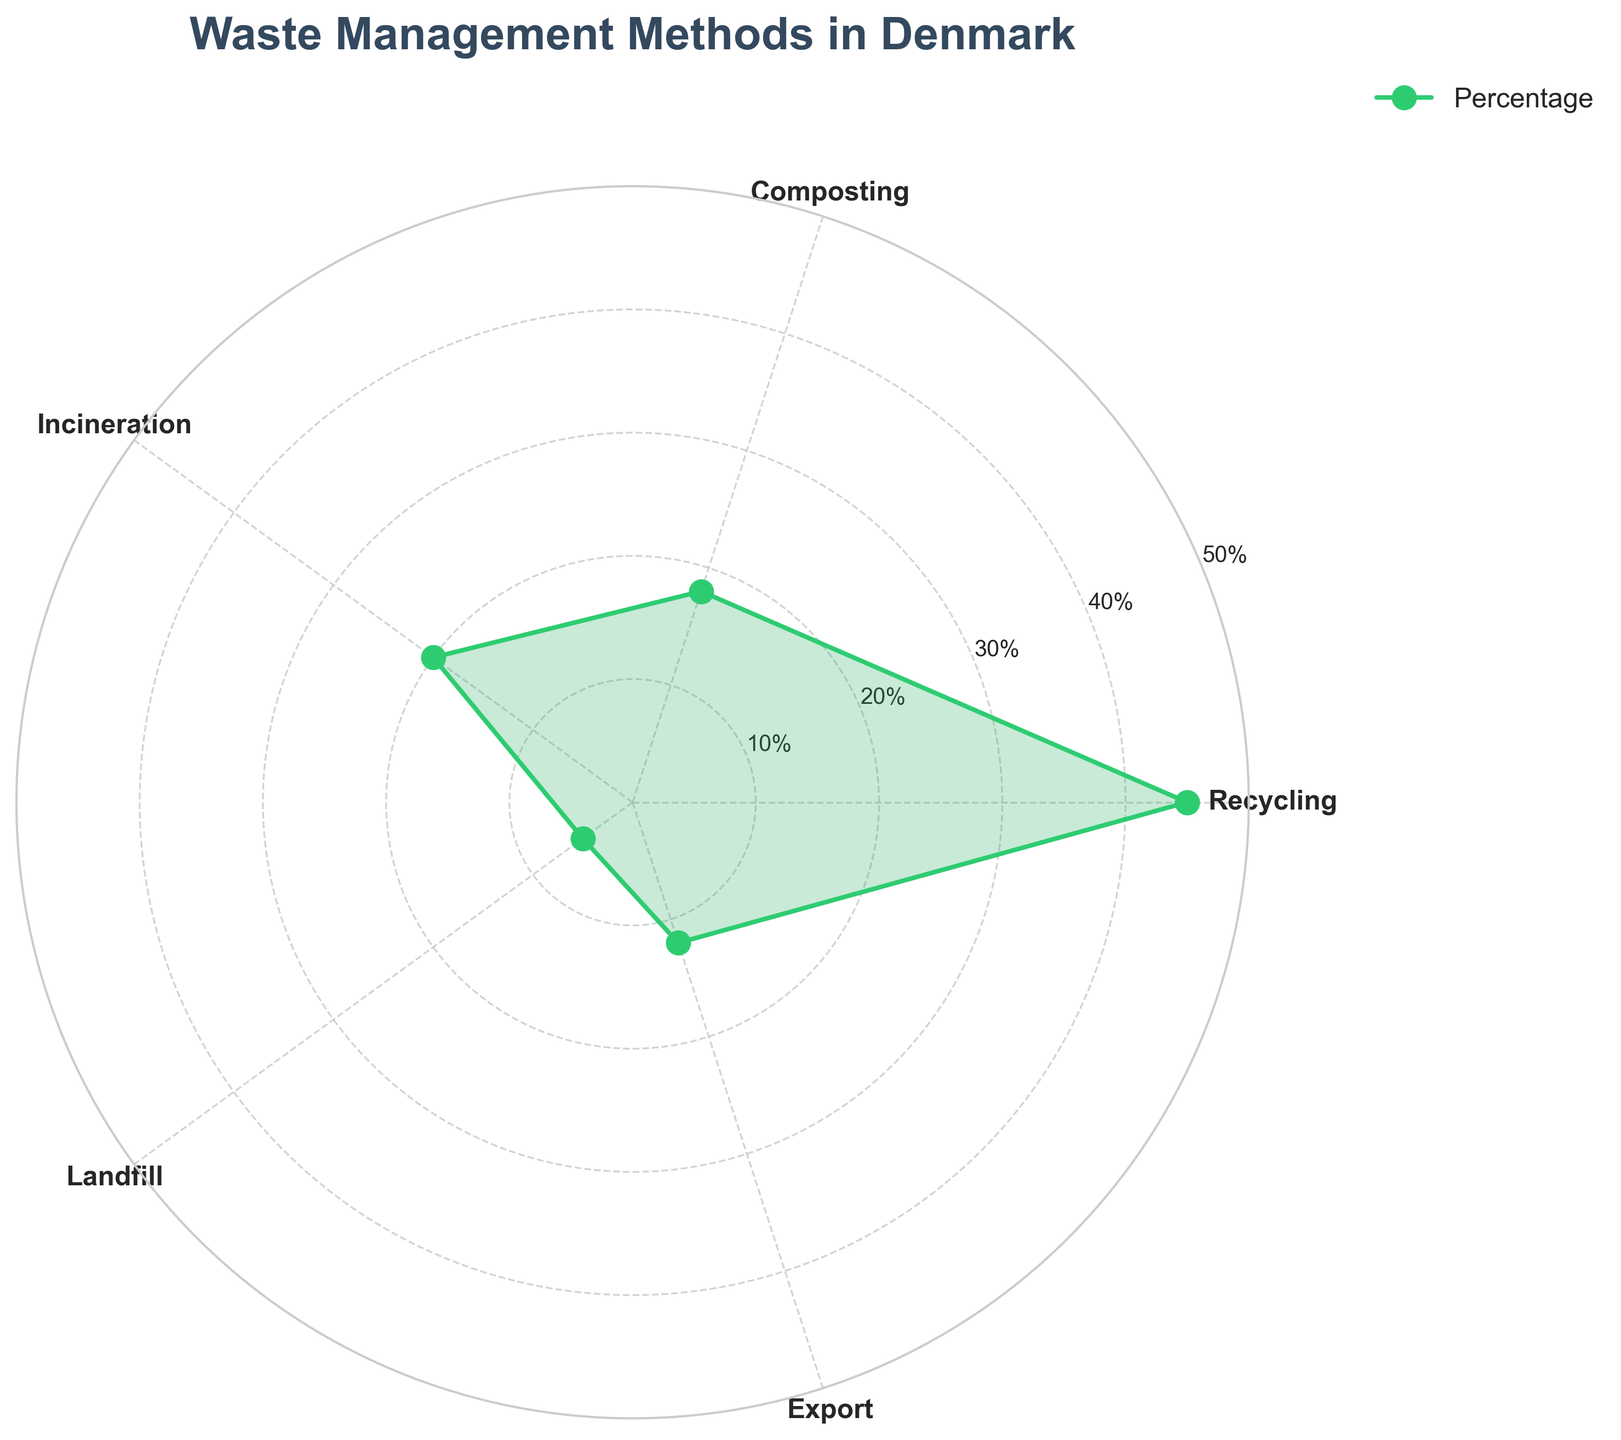What's the title of the chart? The title of the chart is located at the top center of the figure and reads "Waste Management Methods in Denmark".
Answer: Waste Management Methods in Denmark How many waste management methods are displayed? By counting the unique labels along the polar chart’s circumference, we see there are five waste management methods displayed: Recycling, Composting, Incineration, Landfill, and Export.
Answer: Five Which waste management method has the highest percentage? By observing the values on the radial axis and the corresponding labels, Recycling, at 45%, has the highest percentage.
Answer: Recycling What's the percentage for incineration? The radial point for Incineration appears at the 20% mark.
Answer: 20% What is the combined percentage of Recycling and Composting? Recycling is 45% and Composting is 18%. Adding these together: 45% + 18% = 63%.
Answer: 63% Which waste management method has the lowest percentage? By comparing the values on the radial axis, Landfill has the lowest percentage, at 5%.
Answer: Landfill How does the percentage of Export compare to that of Composting? The diagram shows Export at 12% and Composting at 18%. Export's percentage is 6% less than Composting's.
Answer: 6% less What is the average percentage of all waste management methods? The percentages are 45, 18, 20, 5, and 12. Summing them gives 45 + 18 + 20 + 5 + 12 = 100. Dividing by 5 yields an average of 20%.
Answer: 20% What is the range of the percentages displayed? The range is the difference between the highest and lowest values. The highest is 45% (Recycling) and the lowest is 5% (Landfill). So, 45% - 5% = 40%.
Answer: 40% 